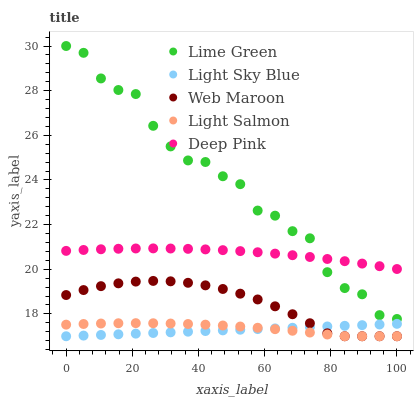Does Light Sky Blue have the minimum area under the curve?
Answer yes or no. Yes. Does Lime Green have the maximum area under the curve?
Answer yes or no. Yes. Does Light Salmon have the minimum area under the curve?
Answer yes or no. No. Does Light Salmon have the maximum area under the curve?
Answer yes or no. No. Is Light Sky Blue the smoothest?
Answer yes or no. Yes. Is Lime Green the roughest?
Answer yes or no. Yes. Is Light Salmon the smoothest?
Answer yes or no. No. Is Light Salmon the roughest?
Answer yes or no. No. Does Web Maroon have the lowest value?
Answer yes or no. Yes. Does Lime Green have the lowest value?
Answer yes or no. No. Does Lime Green have the highest value?
Answer yes or no. Yes. Does Light Salmon have the highest value?
Answer yes or no. No. Is Light Sky Blue less than Lime Green?
Answer yes or no. Yes. Is Lime Green greater than Light Sky Blue?
Answer yes or no. Yes. Does Lime Green intersect Deep Pink?
Answer yes or no. Yes. Is Lime Green less than Deep Pink?
Answer yes or no. No. Is Lime Green greater than Deep Pink?
Answer yes or no. No. Does Light Sky Blue intersect Lime Green?
Answer yes or no. No. 